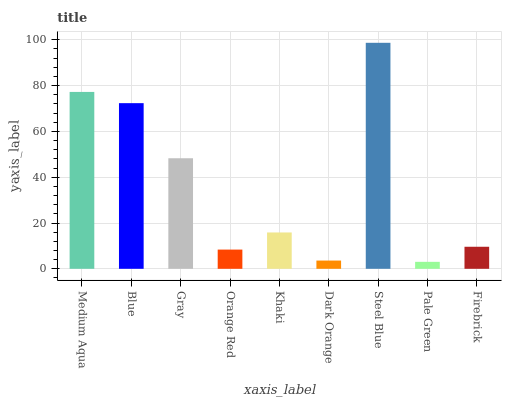Is Pale Green the minimum?
Answer yes or no. Yes. Is Steel Blue the maximum?
Answer yes or no. Yes. Is Blue the minimum?
Answer yes or no. No. Is Blue the maximum?
Answer yes or no. No. Is Medium Aqua greater than Blue?
Answer yes or no. Yes. Is Blue less than Medium Aqua?
Answer yes or no. Yes. Is Blue greater than Medium Aqua?
Answer yes or no. No. Is Medium Aqua less than Blue?
Answer yes or no. No. Is Khaki the high median?
Answer yes or no. Yes. Is Khaki the low median?
Answer yes or no. Yes. Is Blue the high median?
Answer yes or no. No. Is Gray the low median?
Answer yes or no. No. 